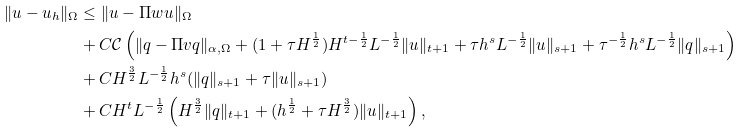<formula> <loc_0><loc_0><loc_500><loc_500>\| u - u _ { h } \| _ { \Omega } & \leq \| u - \Pi w u \| _ { \Omega } \\ & + C \mathcal { C } \left ( \| q - \Pi v q \| _ { \alpha , \Omega } + ( 1 + \tau H ^ { \frac { 1 } { 2 } } ) H ^ { t - \frac { 1 } { 2 } } L ^ { - \frac { 1 } { 2 } } \| u \| _ { t + 1 } + \tau h ^ { s } L ^ { - \frac { 1 } { 2 } } \| u \| _ { s + 1 } + \tau ^ { - \frac { 1 } { 2 } } h ^ { s } L ^ { - \frac { 1 } { 2 } } \| q \| _ { s + 1 } \right ) \\ & + C H ^ { \frac { 3 } { 2 } } L ^ { - \frac { 1 } { 2 } } h ^ { s } ( \| q \| _ { s + 1 } + \tau \| u \| _ { s + 1 } ) \\ & + C H ^ { t } L ^ { - \frac { 1 } { 2 } } \left ( H ^ { \frac { 3 } { 2 } } \| q \| _ { t + 1 } + ( h ^ { \frac { 1 } { 2 } } + \tau H ^ { \frac { 3 } { 2 } } ) \| u \| _ { t + 1 } \right ) ,</formula> 